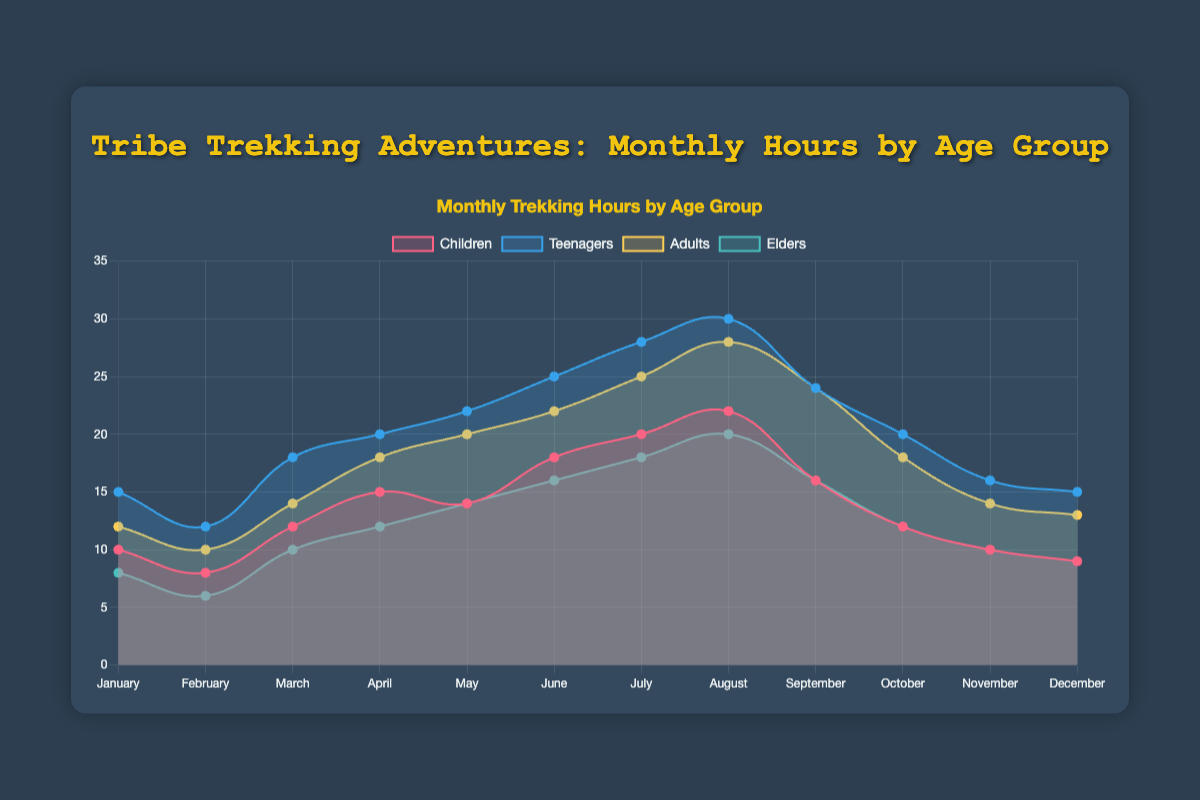What is the title of the chart? The title is typically located at the top of the chart and provides a brief description of its content, which in this case is "Tribe Trekking Adventures: Monthly Hours by Age Group".
Answer: Tribe Trekking Adventures: Monthly Hours by Age Group Which month did the elders spend the most time trekking? Observing the data for elders, August shows the highest value at 20 hours.
Answer: August How many hours did children spend trekking in the month of May? By looking at the children’s data, May is marked with 14 hours spent trekking.
Answer: 14 Which age group spends the fewest trekking hours throughout the year? By summing up the hours for each age group and comparing, the elders have the least total trekking hours.
Answer: Elders What is the difference in trekking hours between adults and teenagers in July? The data shows teenagers spent 28 hours and adults 25 in July. The difference is 28 - 25 = 3 hours.
Answer: 3 How do the trekking hours of children change from January to December? Observing the children’s trend, the hours increase from January (10) to a peak in August (22), then decrease to December (9).
Answer: Increase then decrease What is the average trekking hours of adults over the period of a year? Summing the hours for each month for adults gives 204. Dividing by 12 (months) gives an average of 204 / 12 ≈ 17 hours.
Answer: 17 How do September’s trekking hours compare across all age groups? The hours for September are: Children 16, Teenagers 24, Adults 24, Elders 16. Children and Elders have the same hours, whereas Teenagers and Adults also match each other but have more hours than Children and Elders.
Answer: Teenagers and Adults > Children and Elders Which age group had the most stable (least variable) trekking hours throughout the year? By examining the fluctuations in the plotted lines, the elders have the least variance in their trekking hours over the months.
Answer: Elders What's the seasonal trend for teenagers' trekking hours in summer (June to August)? Teenagers' trekking hours rise steadily during summer: 25 in June, 28 in July, and peak at 30 in August.
Answer: Increasing trend 